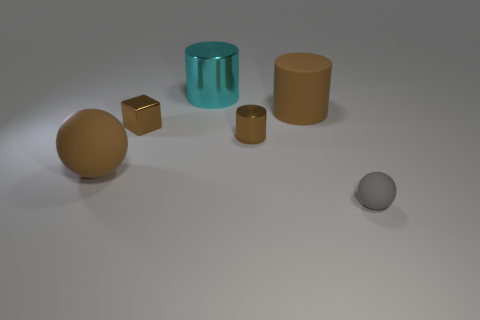Subtract all metal cylinders. How many cylinders are left? 1 Add 4 gray metal blocks. How many objects exist? 10 Subtract 1 balls. How many balls are left? 1 Subtract all purple spheres. Subtract all brown cubes. How many spheres are left? 2 Subtract all red balls. How many cyan cylinders are left? 1 Subtract all small green balls. Subtract all cylinders. How many objects are left? 3 Add 5 brown cubes. How many brown cubes are left? 6 Add 1 big metallic cylinders. How many big metallic cylinders exist? 2 Subtract all brown balls. How many balls are left? 1 Subtract 0 green spheres. How many objects are left? 6 